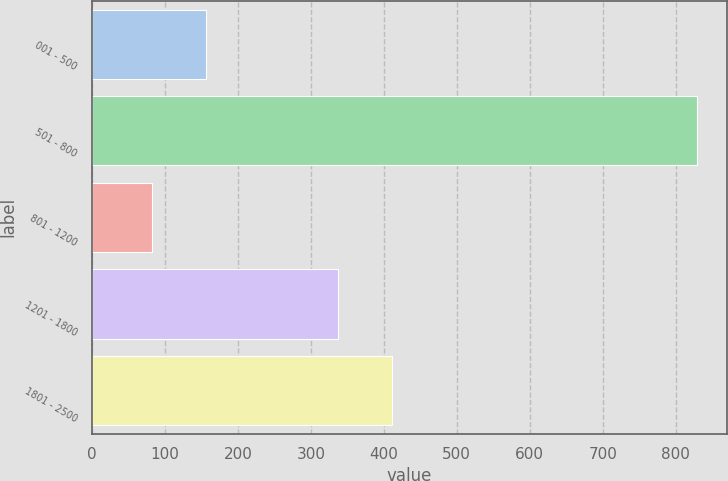Convert chart to OTSL. <chart><loc_0><loc_0><loc_500><loc_500><bar_chart><fcel>001 - 500<fcel>501 - 800<fcel>801 - 1200<fcel>1201 - 1800<fcel>1801 - 2500<nl><fcel>156.7<fcel>829<fcel>82<fcel>337<fcel>411.7<nl></chart> 